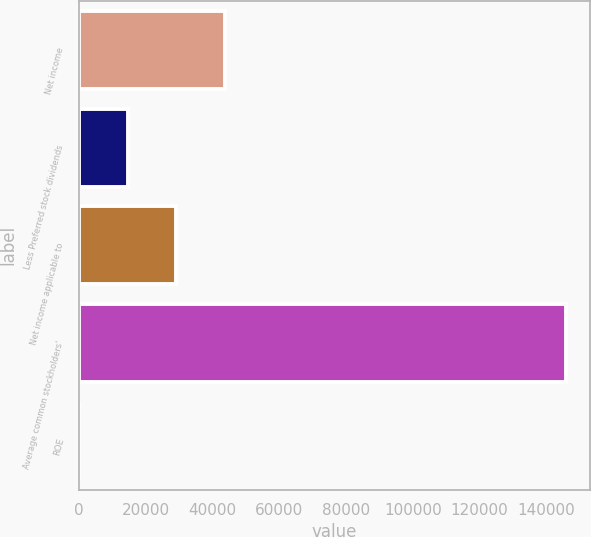Convert chart. <chart><loc_0><loc_0><loc_500><loc_500><bar_chart><fcel>Net income<fcel>Less Preferred stock dividends<fcel>Net income applicable to<fcel>Average common stockholders'<fcel>ROE<nl><fcel>43775.1<fcel>14595.7<fcel>29185.4<fcel>145903<fcel>6<nl></chart> 